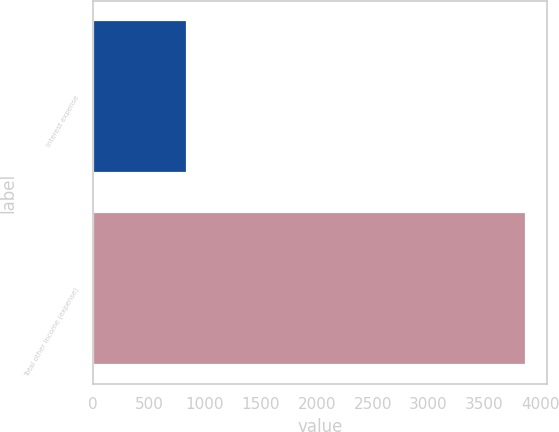Convert chart. <chart><loc_0><loc_0><loc_500><loc_500><bar_chart><fcel>Interest expense<fcel>Total other income (expense)<nl><fcel>839<fcel>3868<nl></chart> 